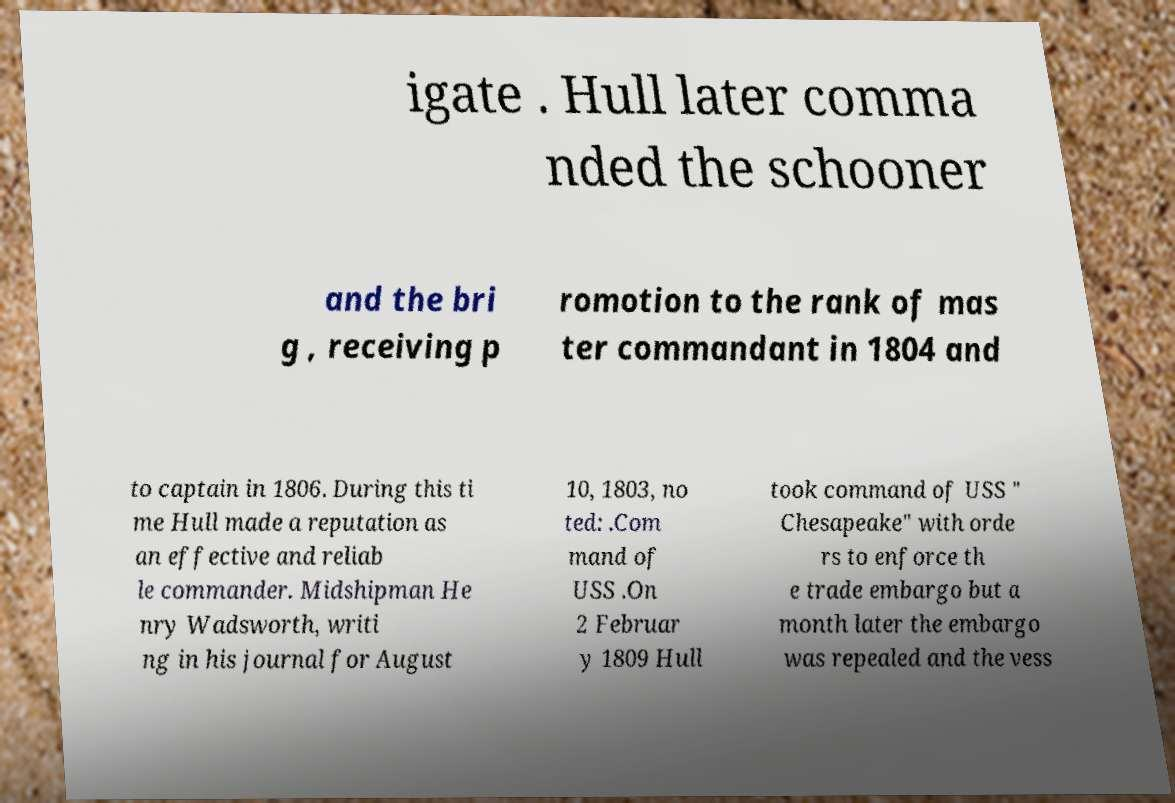Could you assist in decoding the text presented in this image and type it out clearly? igate . Hull later comma nded the schooner and the bri g , receiving p romotion to the rank of mas ter commandant in 1804 and to captain in 1806. During this ti me Hull made a reputation as an effective and reliab le commander. Midshipman He nry Wadsworth, writi ng in his journal for August 10, 1803, no ted: .Com mand of USS .On 2 Februar y 1809 Hull took command of USS " Chesapeake" with orde rs to enforce th e trade embargo but a month later the embargo was repealed and the vess 